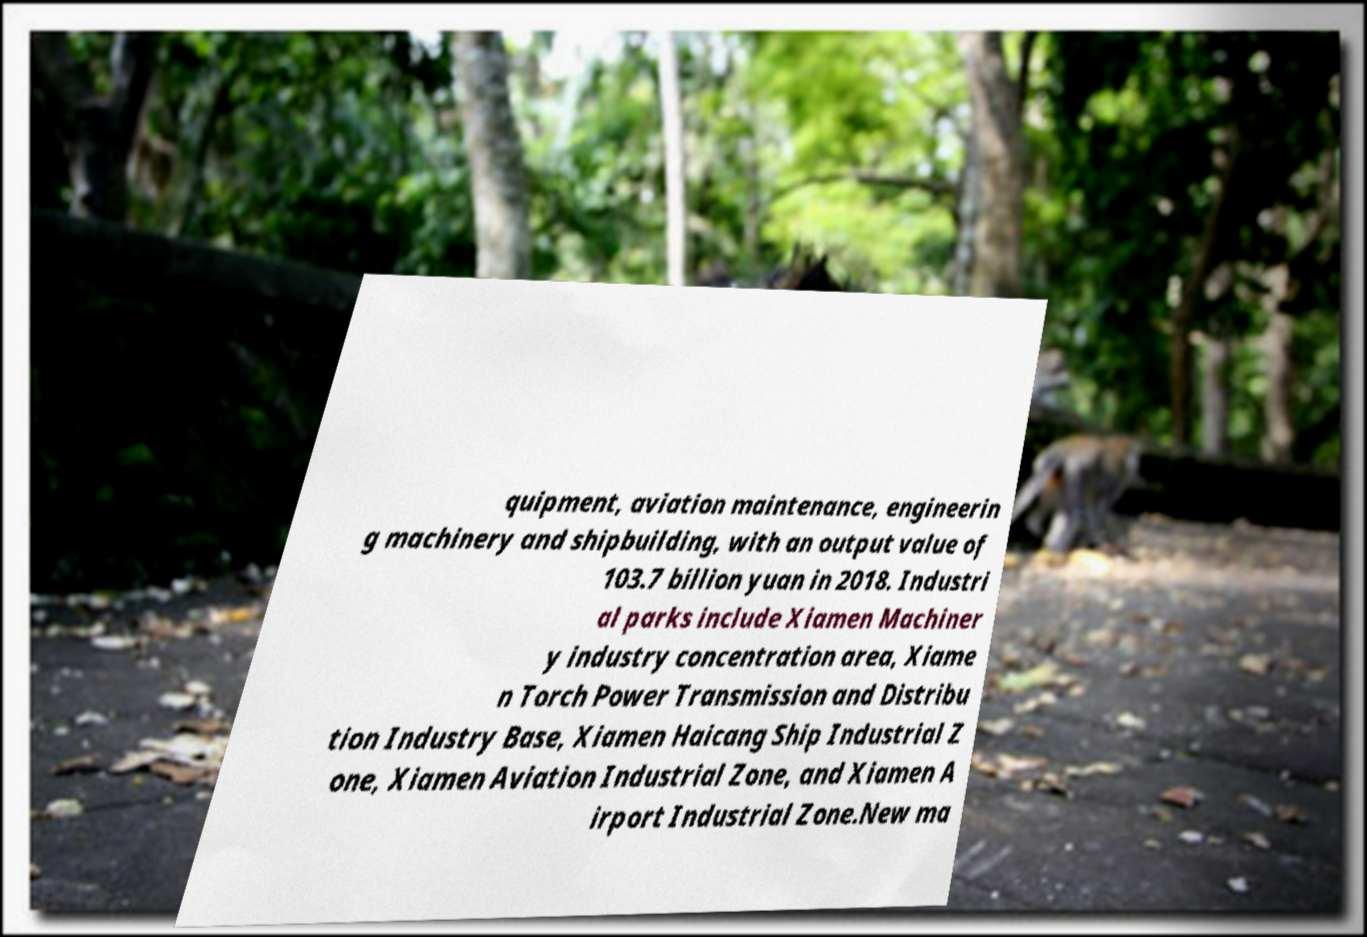I need the written content from this picture converted into text. Can you do that? quipment, aviation maintenance, engineerin g machinery and shipbuilding, with an output value of 103.7 billion yuan in 2018. Industri al parks include Xiamen Machiner y industry concentration area, Xiame n Torch Power Transmission and Distribu tion Industry Base, Xiamen Haicang Ship Industrial Z one, Xiamen Aviation Industrial Zone, and Xiamen A irport Industrial Zone.New ma 